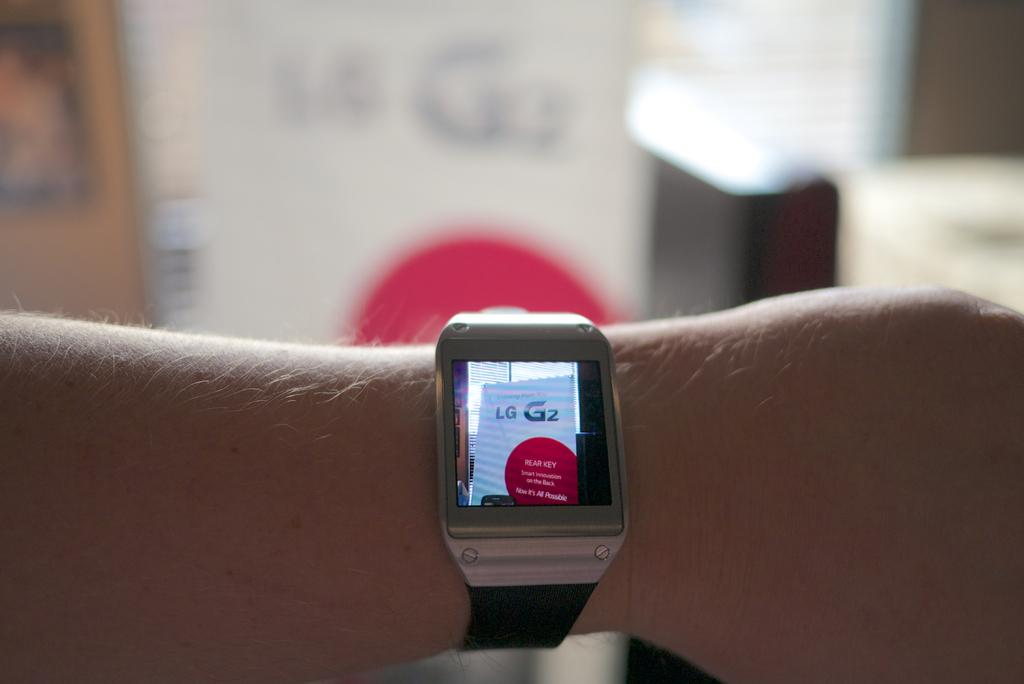<image>
Summarize the visual content of the image. A watch shows the words "REAR KEY" on the display. 